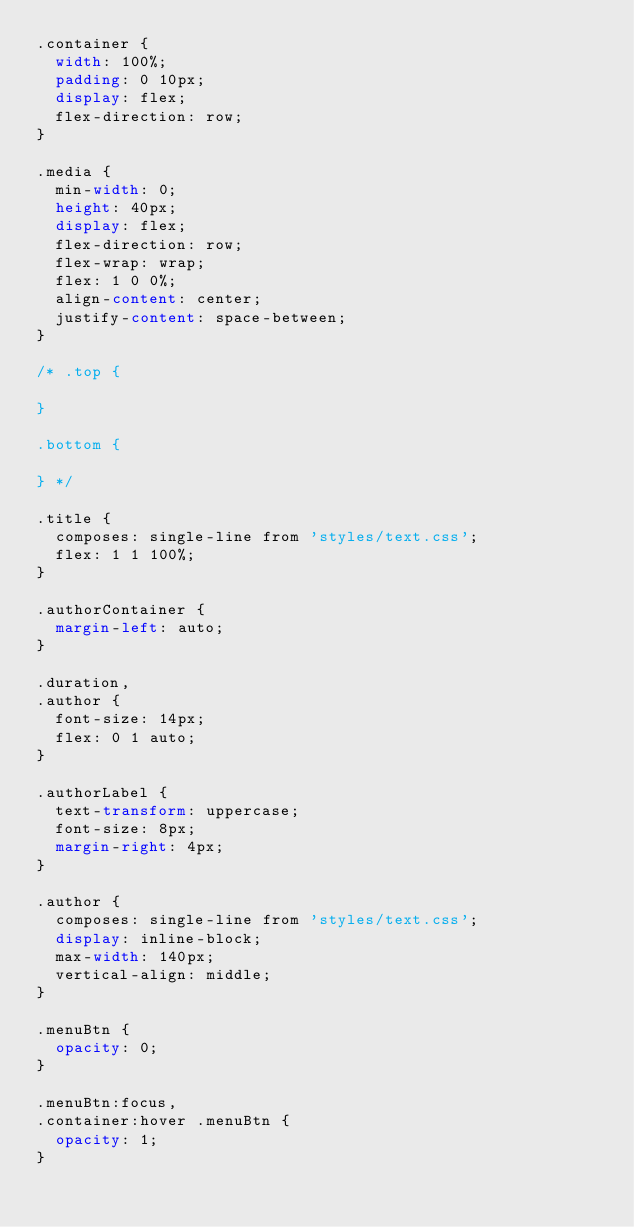Convert code to text. <code><loc_0><loc_0><loc_500><loc_500><_CSS_>.container {
  width: 100%;
  padding: 0 10px;
  display: flex;
  flex-direction: row;
}

.media {
  min-width: 0;
  height: 40px;
  display: flex;
  flex-direction: row;
  flex-wrap: wrap;
  flex: 1 0 0%;
  align-content: center;
  justify-content: space-between;
}

/* .top {

}

.bottom {

} */

.title {
  composes: single-line from 'styles/text.css';
  flex: 1 1 100%;
}

.authorContainer {
  margin-left: auto;
}

.duration,
.author {
  font-size: 14px;
  flex: 0 1 auto;
}

.authorLabel {
  text-transform: uppercase;
  font-size: 8px;
  margin-right: 4px;
}

.author {
  composes: single-line from 'styles/text.css';
  display: inline-block;
  max-width: 140px;
  vertical-align: middle;
}

.menuBtn {
  opacity: 0;
}

.menuBtn:focus,
.container:hover .menuBtn {
  opacity: 1;
}
</code> 